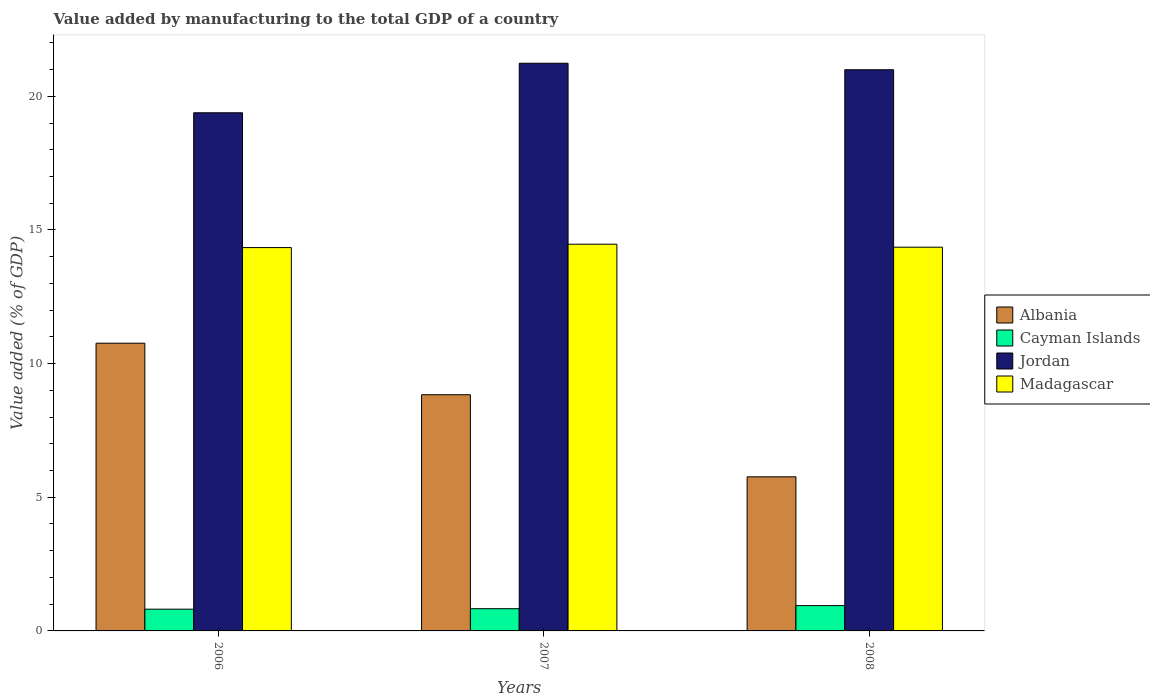Are the number of bars on each tick of the X-axis equal?
Provide a succinct answer. Yes. In how many cases, is the number of bars for a given year not equal to the number of legend labels?
Offer a very short reply. 0. What is the value added by manufacturing to the total GDP in Madagascar in 2008?
Make the answer very short. 14.35. Across all years, what is the maximum value added by manufacturing to the total GDP in Albania?
Offer a terse response. 10.76. Across all years, what is the minimum value added by manufacturing to the total GDP in Madagascar?
Offer a terse response. 14.34. In which year was the value added by manufacturing to the total GDP in Jordan minimum?
Offer a very short reply. 2006. What is the total value added by manufacturing to the total GDP in Madagascar in the graph?
Offer a terse response. 43.16. What is the difference between the value added by manufacturing to the total GDP in Albania in 2006 and that in 2007?
Give a very brief answer. 1.93. What is the difference between the value added by manufacturing to the total GDP in Jordan in 2008 and the value added by manufacturing to the total GDP in Cayman Islands in 2006?
Give a very brief answer. 20.18. What is the average value added by manufacturing to the total GDP in Jordan per year?
Your response must be concise. 20.54. In the year 2008, what is the difference between the value added by manufacturing to the total GDP in Madagascar and value added by manufacturing to the total GDP in Jordan?
Keep it short and to the point. -6.64. In how many years, is the value added by manufacturing to the total GDP in Albania greater than 16 %?
Offer a very short reply. 0. What is the ratio of the value added by manufacturing to the total GDP in Madagascar in 2007 to that in 2008?
Ensure brevity in your answer.  1.01. What is the difference between the highest and the second highest value added by manufacturing to the total GDP in Albania?
Give a very brief answer. 1.93. What is the difference between the highest and the lowest value added by manufacturing to the total GDP in Albania?
Offer a very short reply. 5. Is the sum of the value added by manufacturing to the total GDP in Madagascar in 2006 and 2007 greater than the maximum value added by manufacturing to the total GDP in Albania across all years?
Keep it short and to the point. Yes. What does the 2nd bar from the left in 2007 represents?
Provide a succinct answer. Cayman Islands. What does the 1st bar from the right in 2006 represents?
Offer a terse response. Madagascar. Is it the case that in every year, the sum of the value added by manufacturing to the total GDP in Albania and value added by manufacturing to the total GDP in Jordan is greater than the value added by manufacturing to the total GDP in Madagascar?
Ensure brevity in your answer.  Yes. How many years are there in the graph?
Provide a succinct answer. 3. Are the values on the major ticks of Y-axis written in scientific E-notation?
Provide a succinct answer. No. Does the graph contain grids?
Keep it short and to the point. No. Where does the legend appear in the graph?
Make the answer very short. Center right. How are the legend labels stacked?
Your answer should be compact. Vertical. What is the title of the graph?
Give a very brief answer. Value added by manufacturing to the total GDP of a country. Does "Low & middle income" appear as one of the legend labels in the graph?
Your answer should be very brief. No. What is the label or title of the Y-axis?
Make the answer very short. Value added (% of GDP). What is the Value added (% of GDP) in Albania in 2006?
Your response must be concise. 10.76. What is the Value added (% of GDP) of Cayman Islands in 2006?
Make the answer very short. 0.81. What is the Value added (% of GDP) in Jordan in 2006?
Your response must be concise. 19.38. What is the Value added (% of GDP) in Madagascar in 2006?
Provide a succinct answer. 14.34. What is the Value added (% of GDP) in Albania in 2007?
Make the answer very short. 8.84. What is the Value added (% of GDP) of Cayman Islands in 2007?
Your answer should be compact. 0.83. What is the Value added (% of GDP) of Jordan in 2007?
Offer a terse response. 21.24. What is the Value added (% of GDP) of Madagascar in 2007?
Your answer should be very brief. 14.47. What is the Value added (% of GDP) of Albania in 2008?
Keep it short and to the point. 5.76. What is the Value added (% of GDP) of Cayman Islands in 2008?
Ensure brevity in your answer.  0.95. What is the Value added (% of GDP) in Jordan in 2008?
Your response must be concise. 20.99. What is the Value added (% of GDP) of Madagascar in 2008?
Your answer should be compact. 14.35. Across all years, what is the maximum Value added (% of GDP) of Albania?
Give a very brief answer. 10.76. Across all years, what is the maximum Value added (% of GDP) in Cayman Islands?
Offer a terse response. 0.95. Across all years, what is the maximum Value added (% of GDP) of Jordan?
Keep it short and to the point. 21.24. Across all years, what is the maximum Value added (% of GDP) in Madagascar?
Offer a terse response. 14.47. Across all years, what is the minimum Value added (% of GDP) of Albania?
Ensure brevity in your answer.  5.76. Across all years, what is the minimum Value added (% of GDP) in Cayman Islands?
Give a very brief answer. 0.81. Across all years, what is the minimum Value added (% of GDP) of Jordan?
Make the answer very short. 19.38. Across all years, what is the minimum Value added (% of GDP) in Madagascar?
Ensure brevity in your answer.  14.34. What is the total Value added (% of GDP) of Albania in the graph?
Your response must be concise. 25.36. What is the total Value added (% of GDP) in Cayman Islands in the graph?
Your answer should be compact. 2.59. What is the total Value added (% of GDP) in Jordan in the graph?
Make the answer very short. 61.61. What is the total Value added (% of GDP) of Madagascar in the graph?
Provide a succinct answer. 43.16. What is the difference between the Value added (% of GDP) of Albania in 2006 and that in 2007?
Offer a terse response. 1.93. What is the difference between the Value added (% of GDP) of Cayman Islands in 2006 and that in 2007?
Provide a short and direct response. -0.02. What is the difference between the Value added (% of GDP) of Jordan in 2006 and that in 2007?
Offer a terse response. -1.85. What is the difference between the Value added (% of GDP) of Madagascar in 2006 and that in 2007?
Keep it short and to the point. -0.13. What is the difference between the Value added (% of GDP) in Albania in 2006 and that in 2008?
Your answer should be very brief. 5. What is the difference between the Value added (% of GDP) of Cayman Islands in 2006 and that in 2008?
Make the answer very short. -0.13. What is the difference between the Value added (% of GDP) of Jordan in 2006 and that in 2008?
Your response must be concise. -1.61. What is the difference between the Value added (% of GDP) in Madagascar in 2006 and that in 2008?
Offer a very short reply. -0.01. What is the difference between the Value added (% of GDP) in Albania in 2007 and that in 2008?
Your response must be concise. 3.07. What is the difference between the Value added (% of GDP) of Cayman Islands in 2007 and that in 2008?
Ensure brevity in your answer.  -0.12. What is the difference between the Value added (% of GDP) in Jordan in 2007 and that in 2008?
Your response must be concise. 0.24. What is the difference between the Value added (% of GDP) of Madagascar in 2007 and that in 2008?
Offer a terse response. 0.11. What is the difference between the Value added (% of GDP) in Albania in 2006 and the Value added (% of GDP) in Cayman Islands in 2007?
Offer a very short reply. 9.93. What is the difference between the Value added (% of GDP) of Albania in 2006 and the Value added (% of GDP) of Jordan in 2007?
Your answer should be very brief. -10.47. What is the difference between the Value added (% of GDP) in Albania in 2006 and the Value added (% of GDP) in Madagascar in 2007?
Your answer should be very brief. -3.7. What is the difference between the Value added (% of GDP) in Cayman Islands in 2006 and the Value added (% of GDP) in Jordan in 2007?
Give a very brief answer. -20.42. What is the difference between the Value added (% of GDP) of Cayman Islands in 2006 and the Value added (% of GDP) of Madagascar in 2007?
Your answer should be very brief. -13.65. What is the difference between the Value added (% of GDP) in Jordan in 2006 and the Value added (% of GDP) in Madagascar in 2007?
Provide a succinct answer. 4.92. What is the difference between the Value added (% of GDP) in Albania in 2006 and the Value added (% of GDP) in Cayman Islands in 2008?
Your answer should be compact. 9.82. What is the difference between the Value added (% of GDP) of Albania in 2006 and the Value added (% of GDP) of Jordan in 2008?
Offer a terse response. -10.23. What is the difference between the Value added (% of GDP) of Albania in 2006 and the Value added (% of GDP) of Madagascar in 2008?
Provide a short and direct response. -3.59. What is the difference between the Value added (% of GDP) in Cayman Islands in 2006 and the Value added (% of GDP) in Jordan in 2008?
Make the answer very short. -20.18. What is the difference between the Value added (% of GDP) in Cayman Islands in 2006 and the Value added (% of GDP) in Madagascar in 2008?
Your answer should be very brief. -13.54. What is the difference between the Value added (% of GDP) in Jordan in 2006 and the Value added (% of GDP) in Madagascar in 2008?
Provide a short and direct response. 5.03. What is the difference between the Value added (% of GDP) in Albania in 2007 and the Value added (% of GDP) in Cayman Islands in 2008?
Keep it short and to the point. 7.89. What is the difference between the Value added (% of GDP) in Albania in 2007 and the Value added (% of GDP) in Jordan in 2008?
Provide a short and direct response. -12.16. What is the difference between the Value added (% of GDP) in Albania in 2007 and the Value added (% of GDP) in Madagascar in 2008?
Offer a very short reply. -5.52. What is the difference between the Value added (% of GDP) of Cayman Islands in 2007 and the Value added (% of GDP) of Jordan in 2008?
Your response must be concise. -20.16. What is the difference between the Value added (% of GDP) of Cayman Islands in 2007 and the Value added (% of GDP) of Madagascar in 2008?
Your response must be concise. -13.52. What is the difference between the Value added (% of GDP) of Jordan in 2007 and the Value added (% of GDP) of Madagascar in 2008?
Give a very brief answer. 6.88. What is the average Value added (% of GDP) in Albania per year?
Your answer should be compact. 8.45. What is the average Value added (% of GDP) of Cayman Islands per year?
Make the answer very short. 0.86. What is the average Value added (% of GDP) of Jordan per year?
Make the answer very short. 20.54. What is the average Value added (% of GDP) in Madagascar per year?
Provide a succinct answer. 14.39. In the year 2006, what is the difference between the Value added (% of GDP) of Albania and Value added (% of GDP) of Cayman Islands?
Ensure brevity in your answer.  9.95. In the year 2006, what is the difference between the Value added (% of GDP) in Albania and Value added (% of GDP) in Jordan?
Offer a very short reply. -8.62. In the year 2006, what is the difference between the Value added (% of GDP) in Albania and Value added (% of GDP) in Madagascar?
Keep it short and to the point. -3.58. In the year 2006, what is the difference between the Value added (% of GDP) in Cayman Islands and Value added (% of GDP) in Jordan?
Your answer should be compact. -18.57. In the year 2006, what is the difference between the Value added (% of GDP) in Cayman Islands and Value added (% of GDP) in Madagascar?
Provide a short and direct response. -13.53. In the year 2006, what is the difference between the Value added (% of GDP) of Jordan and Value added (% of GDP) of Madagascar?
Ensure brevity in your answer.  5.04. In the year 2007, what is the difference between the Value added (% of GDP) in Albania and Value added (% of GDP) in Cayman Islands?
Give a very brief answer. 8. In the year 2007, what is the difference between the Value added (% of GDP) of Albania and Value added (% of GDP) of Jordan?
Give a very brief answer. -12.4. In the year 2007, what is the difference between the Value added (% of GDP) of Albania and Value added (% of GDP) of Madagascar?
Your response must be concise. -5.63. In the year 2007, what is the difference between the Value added (% of GDP) in Cayman Islands and Value added (% of GDP) in Jordan?
Ensure brevity in your answer.  -20.4. In the year 2007, what is the difference between the Value added (% of GDP) of Cayman Islands and Value added (% of GDP) of Madagascar?
Ensure brevity in your answer.  -13.63. In the year 2007, what is the difference between the Value added (% of GDP) of Jordan and Value added (% of GDP) of Madagascar?
Your response must be concise. 6.77. In the year 2008, what is the difference between the Value added (% of GDP) in Albania and Value added (% of GDP) in Cayman Islands?
Ensure brevity in your answer.  4.82. In the year 2008, what is the difference between the Value added (% of GDP) of Albania and Value added (% of GDP) of Jordan?
Give a very brief answer. -15.23. In the year 2008, what is the difference between the Value added (% of GDP) of Albania and Value added (% of GDP) of Madagascar?
Your response must be concise. -8.59. In the year 2008, what is the difference between the Value added (% of GDP) of Cayman Islands and Value added (% of GDP) of Jordan?
Give a very brief answer. -20.05. In the year 2008, what is the difference between the Value added (% of GDP) in Cayman Islands and Value added (% of GDP) in Madagascar?
Keep it short and to the point. -13.41. In the year 2008, what is the difference between the Value added (% of GDP) in Jordan and Value added (% of GDP) in Madagascar?
Offer a terse response. 6.64. What is the ratio of the Value added (% of GDP) of Albania in 2006 to that in 2007?
Your answer should be very brief. 1.22. What is the ratio of the Value added (% of GDP) in Cayman Islands in 2006 to that in 2007?
Offer a very short reply. 0.98. What is the ratio of the Value added (% of GDP) in Jordan in 2006 to that in 2007?
Offer a very short reply. 0.91. What is the ratio of the Value added (% of GDP) in Madagascar in 2006 to that in 2007?
Your answer should be compact. 0.99. What is the ratio of the Value added (% of GDP) in Albania in 2006 to that in 2008?
Ensure brevity in your answer.  1.87. What is the ratio of the Value added (% of GDP) of Cayman Islands in 2006 to that in 2008?
Offer a terse response. 0.86. What is the ratio of the Value added (% of GDP) of Jordan in 2006 to that in 2008?
Your answer should be compact. 0.92. What is the ratio of the Value added (% of GDP) of Madagascar in 2006 to that in 2008?
Your answer should be compact. 1. What is the ratio of the Value added (% of GDP) of Albania in 2007 to that in 2008?
Provide a succinct answer. 1.53. What is the ratio of the Value added (% of GDP) in Cayman Islands in 2007 to that in 2008?
Offer a terse response. 0.88. What is the ratio of the Value added (% of GDP) in Jordan in 2007 to that in 2008?
Give a very brief answer. 1.01. What is the difference between the highest and the second highest Value added (% of GDP) of Albania?
Your answer should be very brief. 1.93. What is the difference between the highest and the second highest Value added (% of GDP) in Cayman Islands?
Offer a terse response. 0.12. What is the difference between the highest and the second highest Value added (% of GDP) in Jordan?
Offer a terse response. 0.24. What is the difference between the highest and the second highest Value added (% of GDP) in Madagascar?
Your answer should be compact. 0.11. What is the difference between the highest and the lowest Value added (% of GDP) of Albania?
Give a very brief answer. 5. What is the difference between the highest and the lowest Value added (% of GDP) of Cayman Islands?
Give a very brief answer. 0.13. What is the difference between the highest and the lowest Value added (% of GDP) of Jordan?
Offer a terse response. 1.85. What is the difference between the highest and the lowest Value added (% of GDP) of Madagascar?
Give a very brief answer. 0.13. 